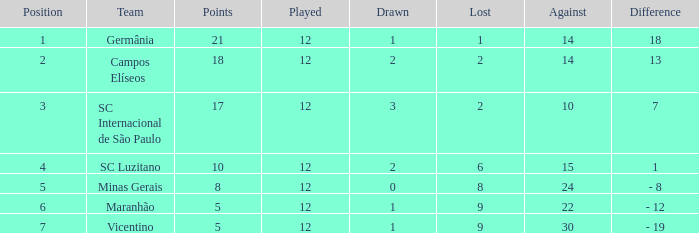What disparity has a points over 10, and a drawn lesser than 2? 18.0. 